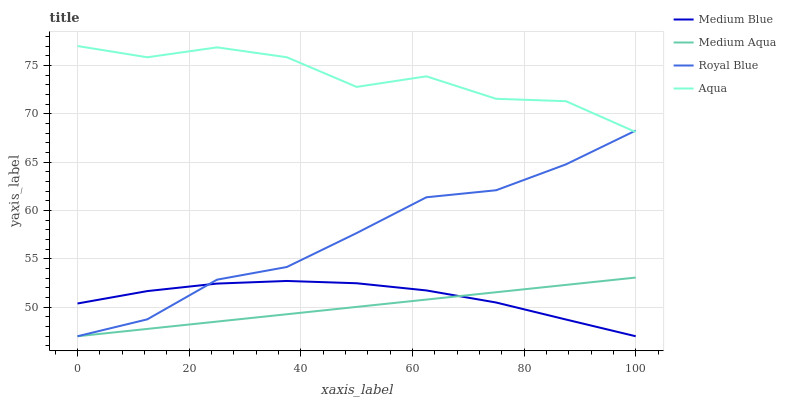Does Medium Aqua have the minimum area under the curve?
Answer yes or no. Yes. Does Aqua have the maximum area under the curve?
Answer yes or no. Yes. Does Medium Blue have the minimum area under the curve?
Answer yes or no. No. Does Medium Blue have the maximum area under the curve?
Answer yes or no. No. Is Medium Aqua the smoothest?
Answer yes or no. Yes. Is Aqua the roughest?
Answer yes or no. Yes. Is Medium Blue the smoothest?
Answer yes or no. No. Is Medium Blue the roughest?
Answer yes or no. No. Does Medium Aqua have the highest value?
Answer yes or no. No. Is Medium Blue less than Aqua?
Answer yes or no. Yes. Is Aqua greater than Medium Blue?
Answer yes or no. Yes. Does Medium Blue intersect Aqua?
Answer yes or no. No. 